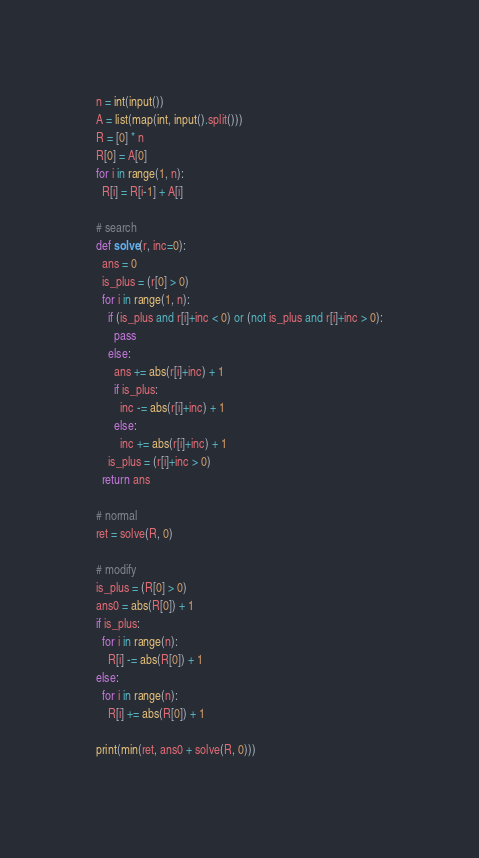<code> <loc_0><loc_0><loc_500><loc_500><_Python_>n = int(input())
A = list(map(int, input().split()))
R = [0] * n
R[0] = A[0]
for i in range(1, n):
  R[i] = R[i-1] + A[i]

# search
def solve(r, inc=0):
  ans = 0
  is_plus = (r[0] > 0)
  for i in range(1, n):
    if (is_plus and r[i]+inc < 0) or (not is_plus and r[i]+inc > 0):
      pass
    else:
      ans += abs(r[i]+inc) + 1
      if is_plus:
        inc -= abs(r[i]+inc) + 1
      else:
        inc += abs(r[i]+inc) + 1
    is_plus = (r[i]+inc > 0)
  return ans

# normal
ret = solve(R, 0)

# modify 
is_plus = (R[0] > 0)
ans0 = abs(R[0]) + 1
if is_plus:
  for i in range(n):
    R[i] -= abs(R[0]) + 1
else:
  for i in range(n):
    R[i] += abs(R[0]) + 1

print(min(ret, ans0 + solve(R, 0)))</code> 